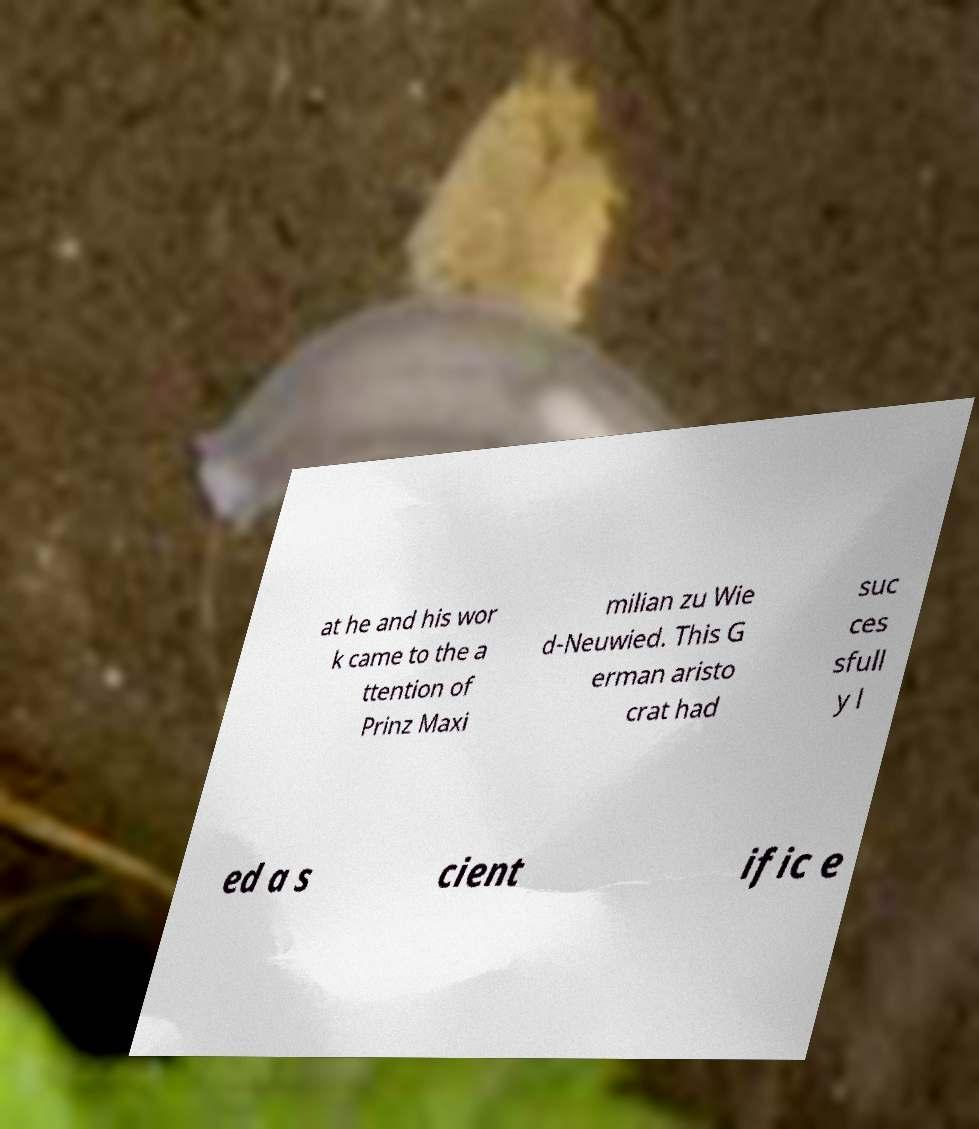What messages or text are displayed in this image? I need them in a readable, typed format. at he and his wor k came to the a ttention of Prinz Maxi milian zu Wie d-Neuwied. This G erman aristo crat had suc ces sfull y l ed a s cient ific e 